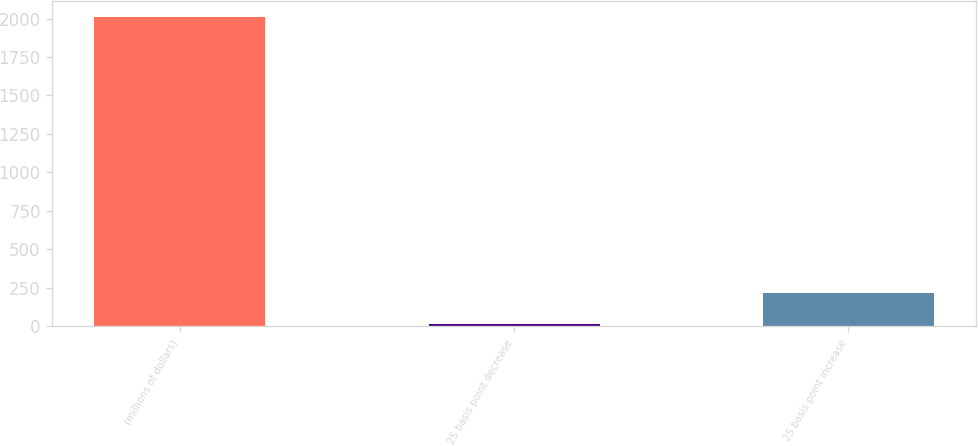<chart> <loc_0><loc_0><loc_500><loc_500><bar_chart><fcel>(millions of dollars)<fcel>25 basis point decrease<fcel>25 basis point increase<nl><fcel>2013<fcel>18.6<fcel>218.04<nl></chart> 